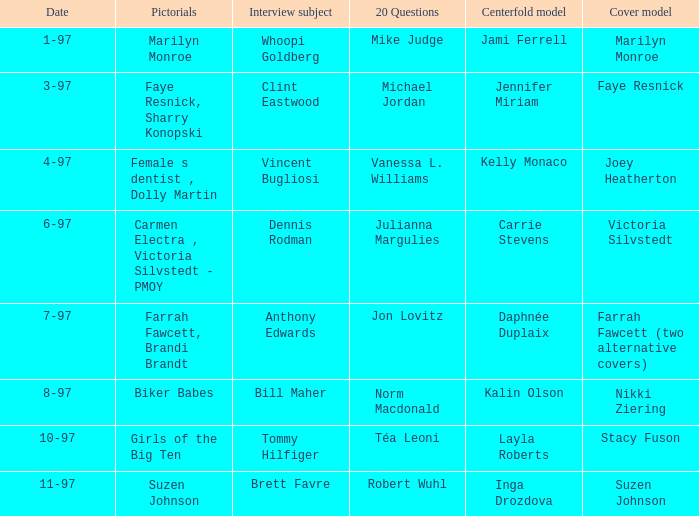Who was the interview subject on the date 1-97? Whoopi Goldberg. 